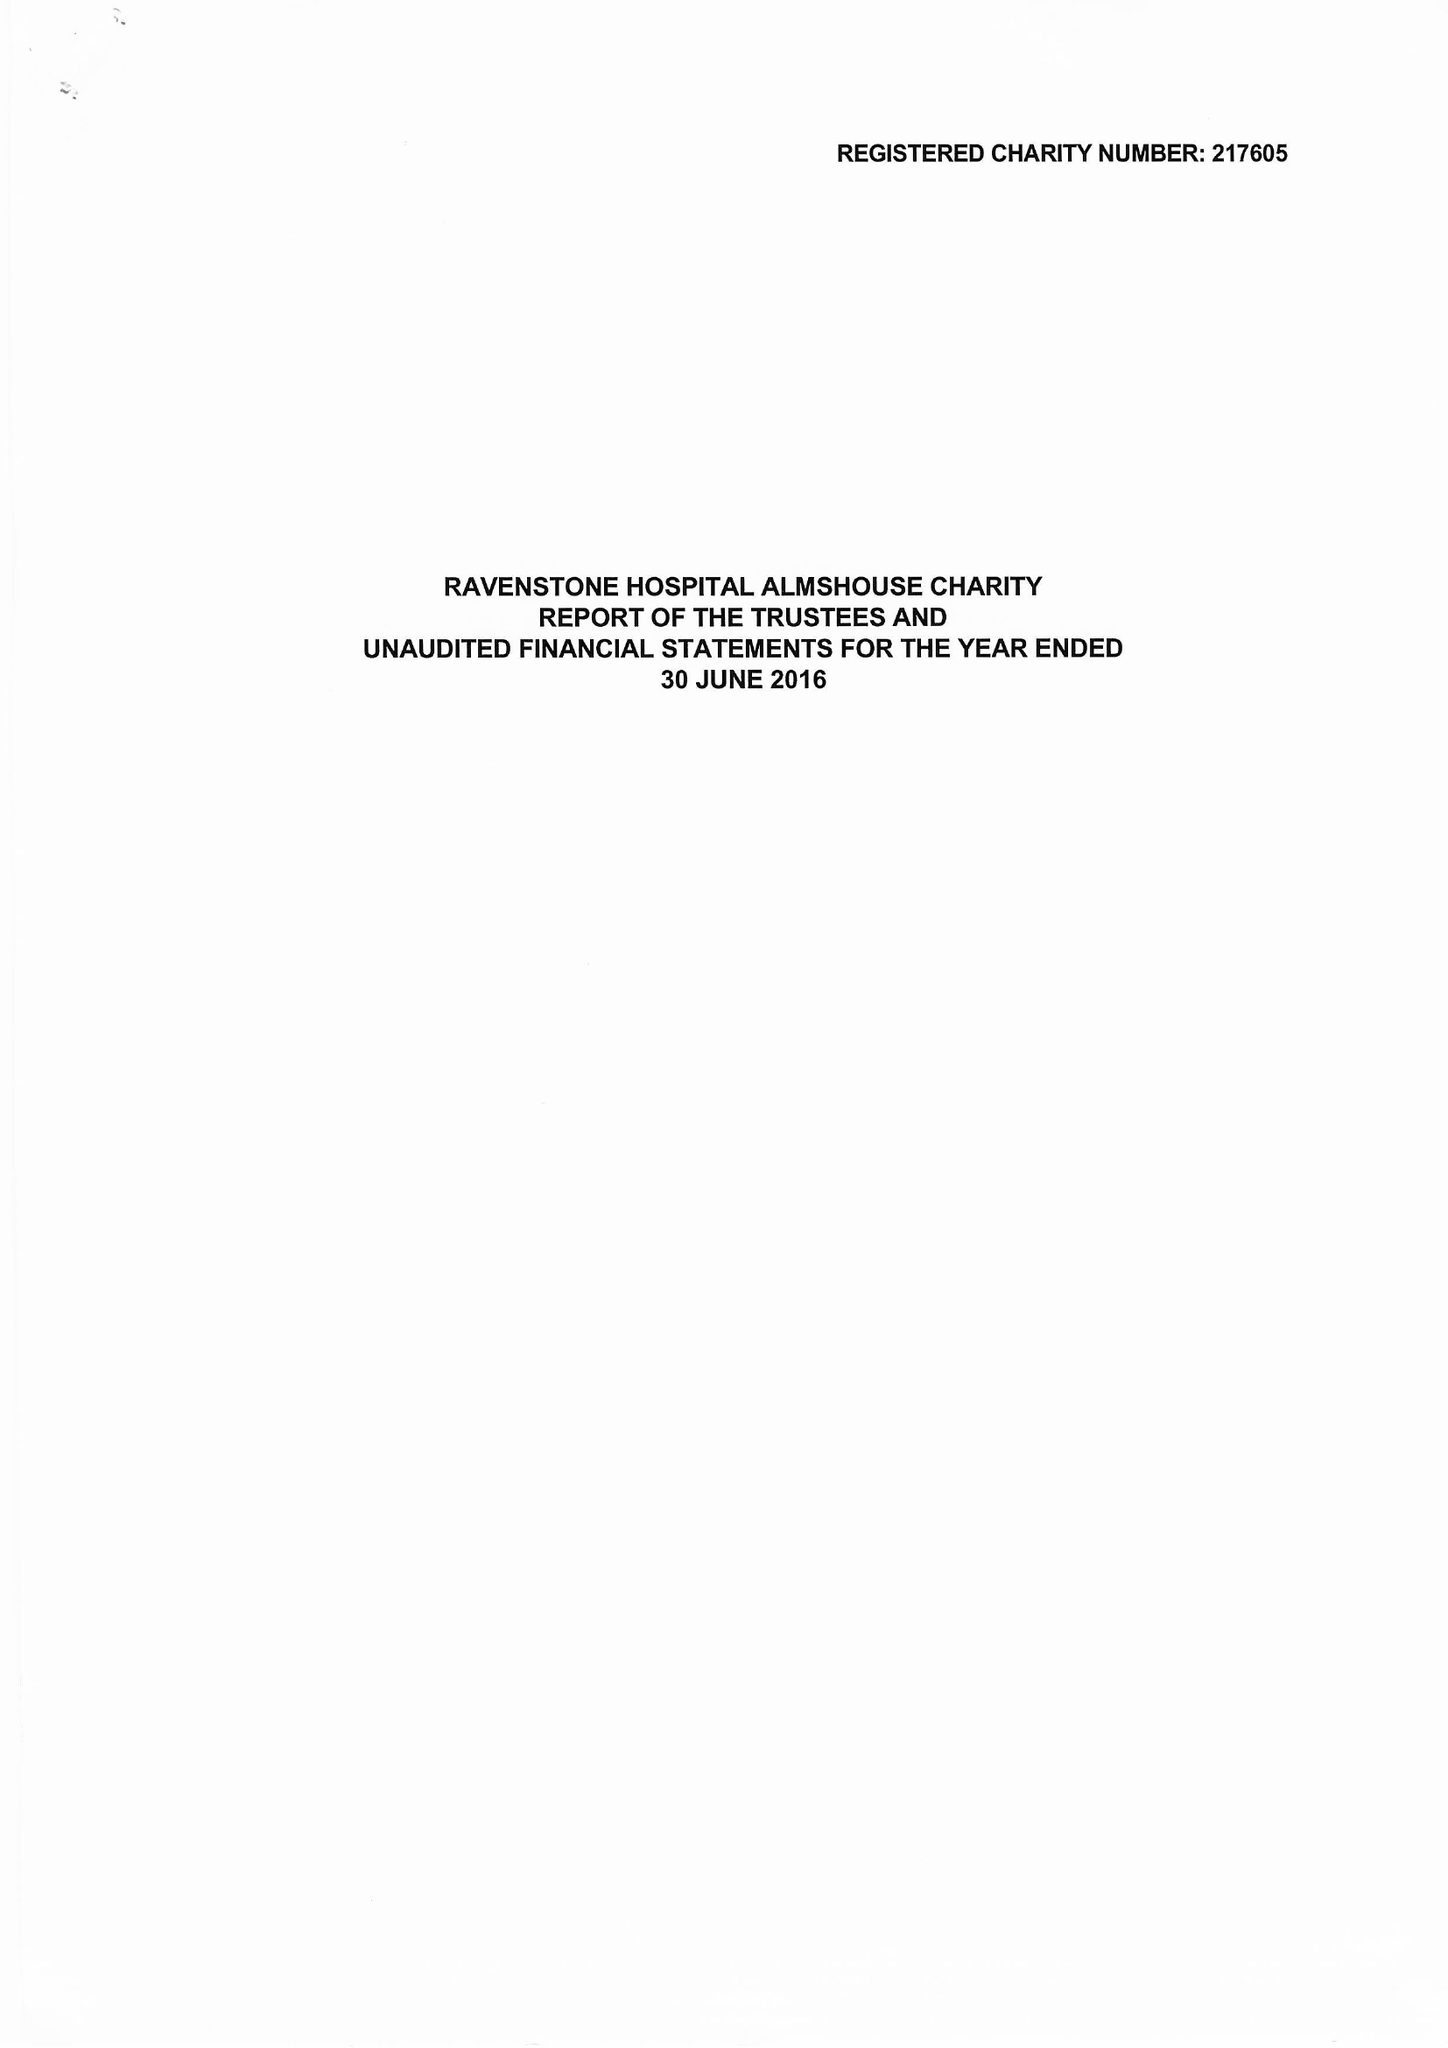What is the value for the charity_name?
Answer the question using a single word or phrase. Ravenstone Hospital Almshouse Charity 